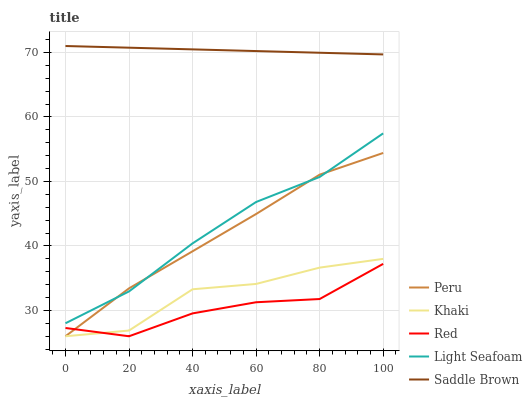Does Red have the minimum area under the curve?
Answer yes or no. Yes. Does Saddle Brown have the maximum area under the curve?
Answer yes or no. Yes. Does Khaki have the minimum area under the curve?
Answer yes or no. No. Does Khaki have the maximum area under the curve?
Answer yes or no. No. Is Saddle Brown the smoothest?
Answer yes or no. Yes. Is Khaki the roughest?
Answer yes or no. Yes. Is Red the smoothest?
Answer yes or no. No. Is Red the roughest?
Answer yes or no. No. Does Khaki have the lowest value?
Answer yes or no. Yes. Does Saddle Brown have the lowest value?
Answer yes or no. No. Does Saddle Brown have the highest value?
Answer yes or no. Yes. Does Khaki have the highest value?
Answer yes or no. No. Is Peru less than Saddle Brown?
Answer yes or no. Yes. Is Saddle Brown greater than Red?
Answer yes or no. Yes. Does Khaki intersect Red?
Answer yes or no. Yes. Is Khaki less than Red?
Answer yes or no. No. Is Khaki greater than Red?
Answer yes or no. No. Does Peru intersect Saddle Brown?
Answer yes or no. No. 